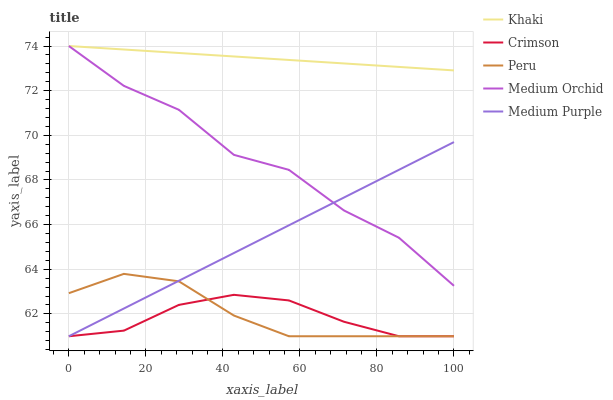Does Crimson have the minimum area under the curve?
Answer yes or no. Yes. Does Khaki have the maximum area under the curve?
Answer yes or no. Yes. Does Medium Purple have the minimum area under the curve?
Answer yes or no. No. Does Medium Purple have the maximum area under the curve?
Answer yes or no. No. Is Medium Purple the smoothest?
Answer yes or no. Yes. Is Medium Orchid the roughest?
Answer yes or no. Yes. Is Medium Orchid the smoothest?
Answer yes or no. No. Is Medium Purple the roughest?
Answer yes or no. No. Does Crimson have the lowest value?
Answer yes or no. Yes. Does Medium Orchid have the lowest value?
Answer yes or no. No. Does Khaki have the highest value?
Answer yes or no. Yes. Does Medium Purple have the highest value?
Answer yes or no. No. Is Crimson less than Medium Orchid?
Answer yes or no. Yes. Is Khaki greater than Peru?
Answer yes or no. Yes. Does Khaki intersect Medium Orchid?
Answer yes or no. Yes. Is Khaki less than Medium Orchid?
Answer yes or no. No. Is Khaki greater than Medium Orchid?
Answer yes or no. No. Does Crimson intersect Medium Orchid?
Answer yes or no. No. 